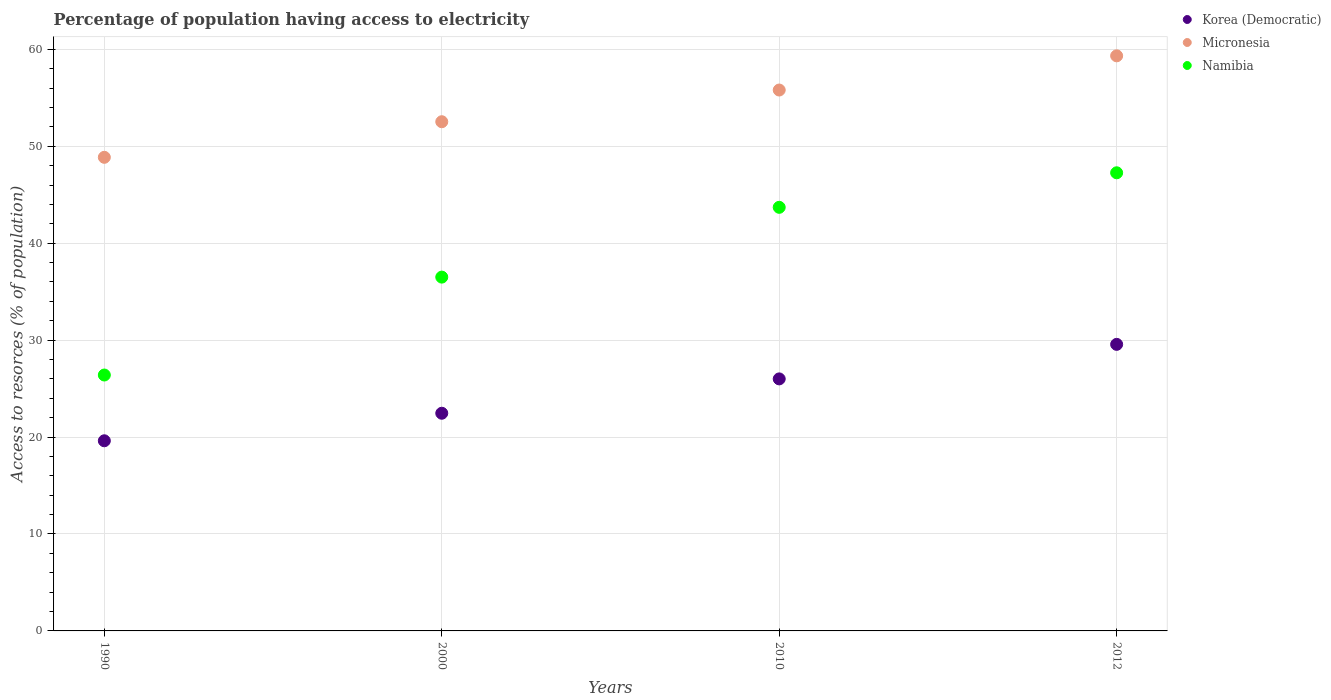How many different coloured dotlines are there?
Provide a succinct answer. 3. What is the percentage of population having access to electricity in Micronesia in 1990?
Give a very brief answer. 48.86. Across all years, what is the maximum percentage of population having access to electricity in Korea (Democratic)?
Offer a very short reply. 29.56. Across all years, what is the minimum percentage of population having access to electricity in Korea (Democratic)?
Your answer should be compact. 19.62. What is the total percentage of population having access to electricity in Namibia in the graph?
Ensure brevity in your answer.  153.86. What is the difference between the percentage of population having access to electricity in Korea (Democratic) in 2000 and that in 2012?
Keep it short and to the point. -7.11. What is the difference between the percentage of population having access to electricity in Micronesia in 2000 and the percentage of population having access to electricity in Korea (Democratic) in 2012?
Provide a succinct answer. 22.97. What is the average percentage of population having access to electricity in Korea (Democratic) per year?
Your answer should be very brief. 24.41. In the year 2012, what is the difference between the percentage of population having access to electricity in Korea (Democratic) and percentage of population having access to electricity in Namibia?
Your answer should be very brief. -17.7. In how many years, is the percentage of population having access to electricity in Namibia greater than 32 %?
Your answer should be very brief. 3. What is the ratio of the percentage of population having access to electricity in Korea (Democratic) in 1990 to that in 2000?
Your answer should be very brief. 0.87. What is the difference between the highest and the second highest percentage of population having access to electricity in Namibia?
Your answer should be compact. 3.56. What is the difference between the highest and the lowest percentage of population having access to electricity in Korea (Democratic)?
Make the answer very short. 9.95. Is it the case that in every year, the sum of the percentage of population having access to electricity in Micronesia and percentage of population having access to electricity in Namibia  is greater than the percentage of population having access to electricity in Korea (Democratic)?
Make the answer very short. Yes. How many dotlines are there?
Provide a succinct answer. 3. What is the difference between two consecutive major ticks on the Y-axis?
Your answer should be compact. 10. Does the graph contain grids?
Offer a terse response. Yes. How many legend labels are there?
Provide a short and direct response. 3. How are the legend labels stacked?
Offer a terse response. Vertical. What is the title of the graph?
Your answer should be very brief. Percentage of population having access to electricity. What is the label or title of the X-axis?
Your answer should be compact. Years. What is the label or title of the Y-axis?
Offer a terse response. Access to resorces (% of population). What is the Access to resorces (% of population) in Korea (Democratic) in 1990?
Offer a terse response. 19.62. What is the Access to resorces (% of population) in Micronesia in 1990?
Your answer should be very brief. 48.86. What is the Access to resorces (% of population) in Namibia in 1990?
Offer a terse response. 26.4. What is the Access to resorces (% of population) of Korea (Democratic) in 2000?
Ensure brevity in your answer.  22.46. What is the Access to resorces (% of population) of Micronesia in 2000?
Offer a very short reply. 52.53. What is the Access to resorces (% of population) in Namibia in 2000?
Ensure brevity in your answer.  36.5. What is the Access to resorces (% of population) in Micronesia in 2010?
Provide a short and direct response. 55.8. What is the Access to resorces (% of population) of Namibia in 2010?
Your answer should be compact. 43.7. What is the Access to resorces (% of population) in Korea (Democratic) in 2012?
Ensure brevity in your answer.  29.56. What is the Access to resorces (% of population) in Micronesia in 2012?
Your response must be concise. 59.33. What is the Access to resorces (% of population) in Namibia in 2012?
Offer a terse response. 47.26. Across all years, what is the maximum Access to resorces (% of population) in Korea (Democratic)?
Provide a succinct answer. 29.56. Across all years, what is the maximum Access to resorces (% of population) in Micronesia?
Keep it short and to the point. 59.33. Across all years, what is the maximum Access to resorces (% of population) in Namibia?
Make the answer very short. 47.26. Across all years, what is the minimum Access to resorces (% of population) in Korea (Democratic)?
Make the answer very short. 19.62. Across all years, what is the minimum Access to resorces (% of population) of Micronesia?
Your answer should be compact. 48.86. Across all years, what is the minimum Access to resorces (% of population) of Namibia?
Give a very brief answer. 26.4. What is the total Access to resorces (% of population) in Korea (Democratic) in the graph?
Your answer should be very brief. 97.63. What is the total Access to resorces (% of population) of Micronesia in the graph?
Ensure brevity in your answer.  216.52. What is the total Access to resorces (% of population) in Namibia in the graph?
Provide a succinct answer. 153.86. What is the difference between the Access to resorces (% of population) of Korea (Democratic) in 1990 and that in 2000?
Offer a terse response. -2.84. What is the difference between the Access to resorces (% of population) in Micronesia in 1990 and that in 2000?
Your answer should be very brief. -3.67. What is the difference between the Access to resorces (% of population) in Korea (Democratic) in 1990 and that in 2010?
Your answer should be very brief. -6.38. What is the difference between the Access to resorces (% of population) in Micronesia in 1990 and that in 2010?
Offer a very short reply. -6.94. What is the difference between the Access to resorces (% of population) of Namibia in 1990 and that in 2010?
Keep it short and to the point. -17.3. What is the difference between the Access to resorces (% of population) of Korea (Democratic) in 1990 and that in 2012?
Ensure brevity in your answer.  -9.95. What is the difference between the Access to resorces (% of population) in Micronesia in 1990 and that in 2012?
Your answer should be very brief. -10.47. What is the difference between the Access to resorces (% of population) of Namibia in 1990 and that in 2012?
Make the answer very short. -20.86. What is the difference between the Access to resorces (% of population) in Korea (Democratic) in 2000 and that in 2010?
Make the answer very short. -3.54. What is the difference between the Access to resorces (% of population) of Micronesia in 2000 and that in 2010?
Offer a very short reply. -3.27. What is the difference between the Access to resorces (% of population) of Namibia in 2000 and that in 2010?
Offer a very short reply. -7.2. What is the difference between the Access to resorces (% of population) of Korea (Democratic) in 2000 and that in 2012?
Provide a succinct answer. -7.11. What is the difference between the Access to resorces (% of population) of Micronesia in 2000 and that in 2012?
Provide a short and direct response. -6.8. What is the difference between the Access to resorces (% of population) in Namibia in 2000 and that in 2012?
Keep it short and to the point. -10.76. What is the difference between the Access to resorces (% of population) of Korea (Democratic) in 2010 and that in 2012?
Your response must be concise. -3.56. What is the difference between the Access to resorces (% of population) of Micronesia in 2010 and that in 2012?
Keep it short and to the point. -3.53. What is the difference between the Access to resorces (% of population) in Namibia in 2010 and that in 2012?
Your response must be concise. -3.56. What is the difference between the Access to resorces (% of population) of Korea (Democratic) in 1990 and the Access to resorces (% of population) of Micronesia in 2000?
Make the answer very short. -32.91. What is the difference between the Access to resorces (% of population) of Korea (Democratic) in 1990 and the Access to resorces (% of population) of Namibia in 2000?
Make the answer very short. -16.88. What is the difference between the Access to resorces (% of population) of Micronesia in 1990 and the Access to resorces (% of population) of Namibia in 2000?
Provide a short and direct response. 12.36. What is the difference between the Access to resorces (% of population) in Korea (Democratic) in 1990 and the Access to resorces (% of population) in Micronesia in 2010?
Provide a succinct answer. -36.18. What is the difference between the Access to resorces (% of population) in Korea (Democratic) in 1990 and the Access to resorces (% of population) in Namibia in 2010?
Make the answer very short. -24.08. What is the difference between the Access to resorces (% of population) in Micronesia in 1990 and the Access to resorces (% of population) in Namibia in 2010?
Offer a terse response. 5.16. What is the difference between the Access to resorces (% of population) in Korea (Democratic) in 1990 and the Access to resorces (% of population) in Micronesia in 2012?
Ensure brevity in your answer.  -39.71. What is the difference between the Access to resorces (% of population) of Korea (Democratic) in 1990 and the Access to resorces (% of population) of Namibia in 2012?
Provide a succinct answer. -27.65. What is the difference between the Access to resorces (% of population) in Micronesia in 1990 and the Access to resorces (% of population) in Namibia in 2012?
Make the answer very short. 1.6. What is the difference between the Access to resorces (% of population) of Korea (Democratic) in 2000 and the Access to resorces (% of population) of Micronesia in 2010?
Give a very brief answer. -33.34. What is the difference between the Access to resorces (% of population) of Korea (Democratic) in 2000 and the Access to resorces (% of population) of Namibia in 2010?
Your answer should be very brief. -21.24. What is the difference between the Access to resorces (% of population) in Micronesia in 2000 and the Access to resorces (% of population) in Namibia in 2010?
Your answer should be very brief. 8.83. What is the difference between the Access to resorces (% of population) of Korea (Democratic) in 2000 and the Access to resorces (% of population) of Micronesia in 2012?
Give a very brief answer. -36.87. What is the difference between the Access to resorces (% of population) of Korea (Democratic) in 2000 and the Access to resorces (% of population) of Namibia in 2012?
Give a very brief answer. -24.81. What is the difference between the Access to resorces (% of population) of Micronesia in 2000 and the Access to resorces (% of population) of Namibia in 2012?
Give a very brief answer. 5.27. What is the difference between the Access to resorces (% of population) of Korea (Democratic) in 2010 and the Access to resorces (% of population) of Micronesia in 2012?
Provide a succinct answer. -33.33. What is the difference between the Access to resorces (% of population) of Korea (Democratic) in 2010 and the Access to resorces (% of population) of Namibia in 2012?
Offer a terse response. -21.26. What is the difference between the Access to resorces (% of population) of Micronesia in 2010 and the Access to resorces (% of population) of Namibia in 2012?
Offer a very short reply. 8.54. What is the average Access to resorces (% of population) of Korea (Democratic) per year?
Ensure brevity in your answer.  24.41. What is the average Access to resorces (% of population) in Micronesia per year?
Ensure brevity in your answer.  54.13. What is the average Access to resorces (% of population) in Namibia per year?
Give a very brief answer. 38.47. In the year 1990, what is the difference between the Access to resorces (% of population) of Korea (Democratic) and Access to resorces (% of population) of Micronesia?
Your answer should be very brief. -29.24. In the year 1990, what is the difference between the Access to resorces (% of population) of Korea (Democratic) and Access to resorces (% of population) of Namibia?
Offer a terse response. -6.78. In the year 1990, what is the difference between the Access to resorces (% of population) in Micronesia and Access to resorces (% of population) in Namibia?
Provide a short and direct response. 22.46. In the year 2000, what is the difference between the Access to resorces (% of population) in Korea (Democratic) and Access to resorces (% of population) in Micronesia?
Your answer should be compact. -30.07. In the year 2000, what is the difference between the Access to resorces (% of population) of Korea (Democratic) and Access to resorces (% of population) of Namibia?
Your answer should be compact. -14.04. In the year 2000, what is the difference between the Access to resorces (% of population) in Micronesia and Access to resorces (% of population) in Namibia?
Keep it short and to the point. 16.03. In the year 2010, what is the difference between the Access to resorces (% of population) of Korea (Democratic) and Access to resorces (% of population) of Micronesia?
Keep it short and to the point. -29.8. In the year 2010, what is the difference between the Access to resorces (% of population) of Korea (Democratic) and Access to resorces (% of population) of Namibia?
Your answer should be compact. -17.7. In the year 2012, what is the difference between the Access to resorces (% of population) in Korea (Democratic) and Access to resorces (% of population) in Micronesia?
Provide a short and direct response. -29.77. In the year 2012, what is the difference between the Access to resorces (% of population) of Korea (Democratic) and Access to resorces (% of population) of Namibia?
Provide a short and direct response. -17.7. In the year 2012, what is the difference between the Access to resorces (% of population) in Micronesia and Access to resorces (% of population) in Namibia?
Provide a short and direct response. 12.07. What is the ratio of the Access to resorces (% of population) in Korea (Democratic) in 1990 to that in 2000?
Ensure brevity in your answer.  0.87. What is the ratio of the Access to resorces (% of population) in Micronesia in 1990 to that in 2000?
Ensure brevity in your answer.  0.93. What is the ratio of the Access to resorces (% of population) in Namibia in 1990 to that in 2000?
Provide a short and direct response. 0.72. What is the ratio of the Access to resorces (% of population) of Korea (Democratic) in 1990 to that in 2010?
Provide a short and direct response. 0.75. What is the ratio of the Access to resorces (% of population) of Micronesia in 1990 to that in 2010?
Your answer should be very brief. 0.88. What is the ratio of the Access to resorces (% of population) of Namibia in 1990 to that in 2010?
Your answer should be compact. 0.6. What is the ratio of the Access to resorces (% of population) of Korea (Democratic) in 1990 to that in 2012?
Give a very brief answer. 0.66. What is the ratio of the Access to resorces (% of population) in Micronesia in 1990 to that in 2012?
Offer a terse response. 0.82. What is the ratio of the Access to resorces (% of population) in Namibia in 1990 to that in 2012?
Your response must be concise. 0.56. What is the ratio of the Access to resorces (% of population) in Korea (Democratic) in 2000 to that in 2010?
Make the answer very short. 0.86. What is the ratio of the Access to resorces (% of population) in Micronesia in 2000 to that in 2010?
Give a very brief answer. 0.94. What is the ratio of the Access to resorces (% of population) in Namibia in 2000 to that in 2010?
Your response must be concise. 0.84. What is the ratio of the Access to resorces (% of population) in Korea (Democratic) in 2000 to that in 2012?
Offer a terse response. 0.76. What is the ratio of the Access to resorces (% of population) in Micronesia in 2000 to that in 2012?
Offer a very short reply. 0.89. What is the ratio of the Access to resorces (% of population) of Namibia in 2000 to that in 2012?
Provide a short and direct response. 0.77. What is the ratio of the Access to resorces (% of population) in Korea (Democratic) in 2010 to that in 2012?
Your response must be concise. 0.88. What is the ratio of the Access to resorces (% of population) in Micronesia in 2010 to that in 2012?
Offer a terse response. 0.94. What is the ratio of the Access to resorces (% of population) in Namibia in 2010 to that in 2012?
Provide a succinct answer. 0.92. What is the difference between the highest and the second highest Access to resorces (% of population) of Korea (Democratic)?
Provide a succinct answer. 3.56. What is the difference between the highest and the second highest Access to resorces (% of population) in Micronesia?
Keep it short and to the point. 3.53. What is the difference between the highest and the second highest Access to resorces (% of population) of Namibia?
Provide a short and direct response. 3.56. What is the difference between the highest and the lowest Access to resorces (% of population) in Korea (Democratic)?
Your answer should be compact. 9.95. What is the difference between the highest and the lowest Access to resorces (% of population) of Micronesia?
Offer a very short reply. 10.47. What is the difference between the highest and the lowest Access to resorces (% of population) in Namibia?
Provide a short and direct response. 20.86. 